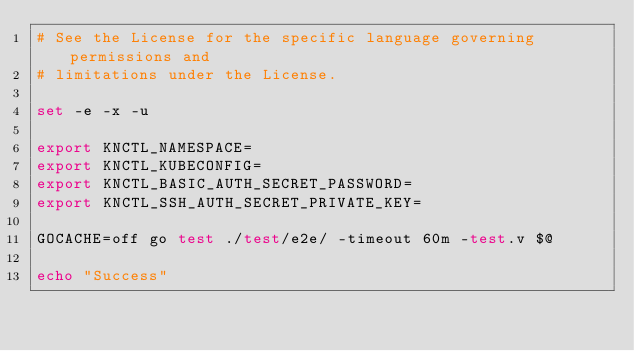Convert code to text. <code><loc_0><loc_0><loc_500><loc_500><_Bash_># See the License for the specific language governing permissions and
# limitations under the License.

set -e -x -u

export KNCTL_NAMESPACE=
export KNCTL_KUBECONFIG=
export KNCTL_BASIC_AUTH_SECRET_PASSWORD=
export KNCTL_SSH_AUTH_SECRET_PRIVATE_KEY=

GOCACHE=off go test ./test/e2e/ -timeout 60m -test.v $@

echo "Success"
</code> 